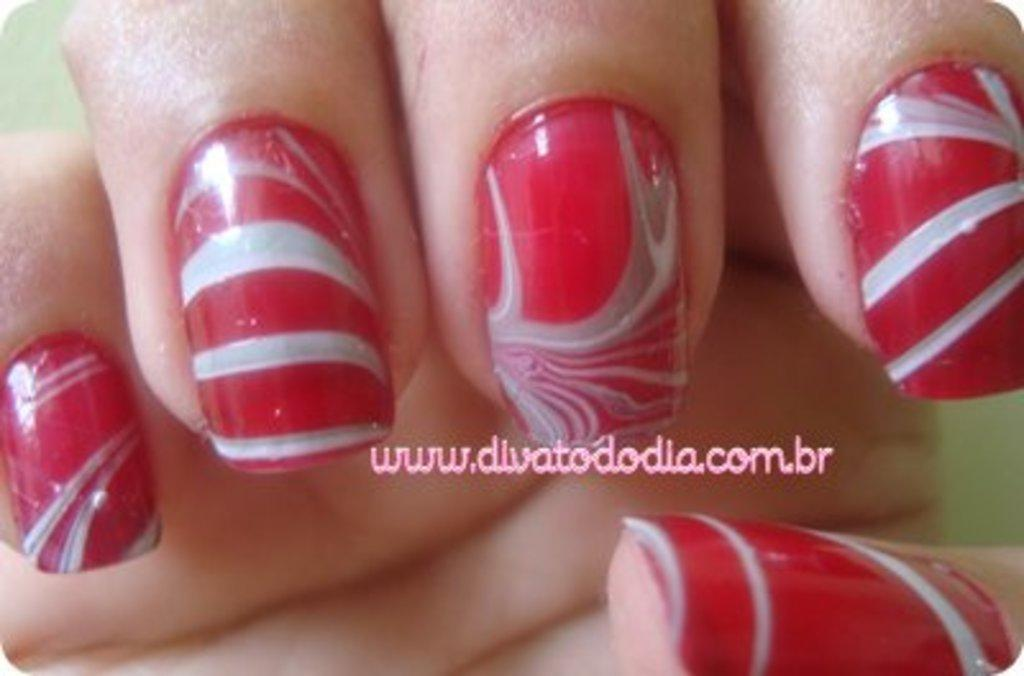Provide a one-sentence caption for the provided image. A set of painted fingernails with the website divatododia listed. 